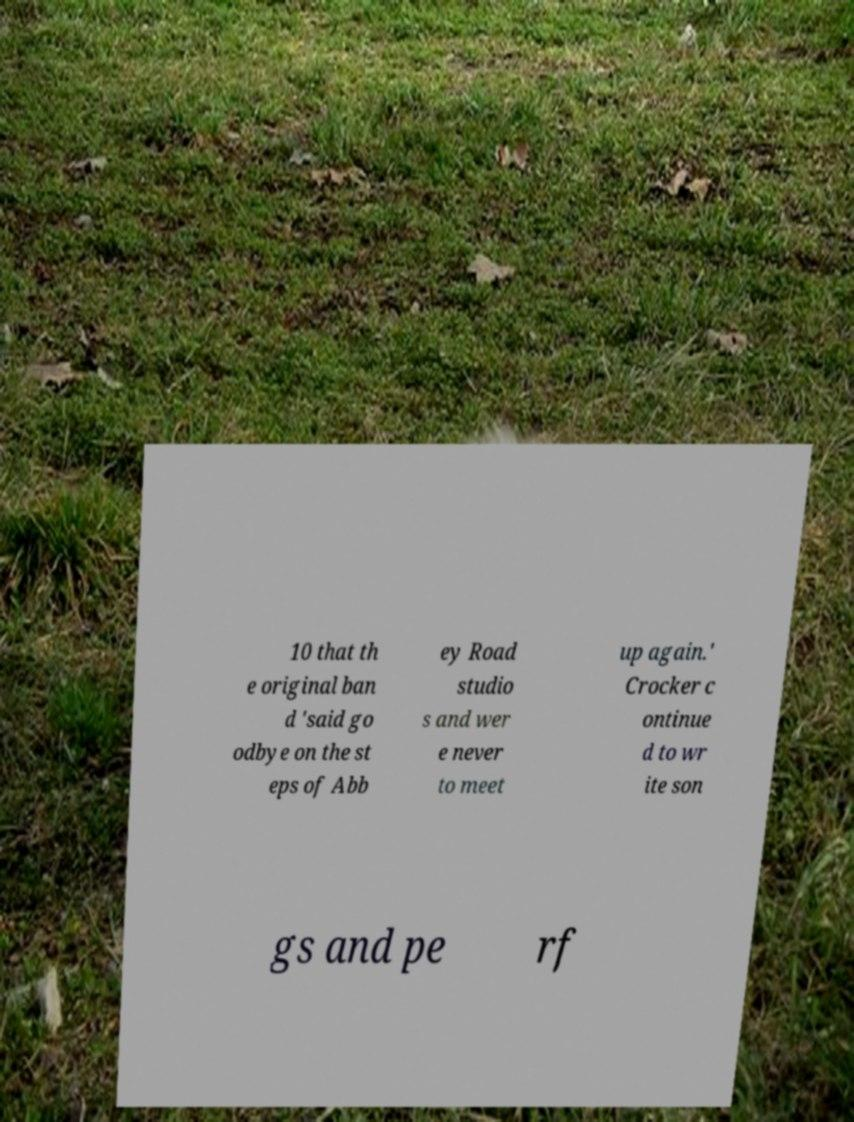Can you read and provide the text displayed in the image?This photo seems to have some interesting text. Can you extract and type it out for me? 10 that th e original ban d 'said go odbye on the st eps of Abb ey Road studio s and wer e never to meet up again.' Crocker c ontinue d to wr ite son gs and pe rf 